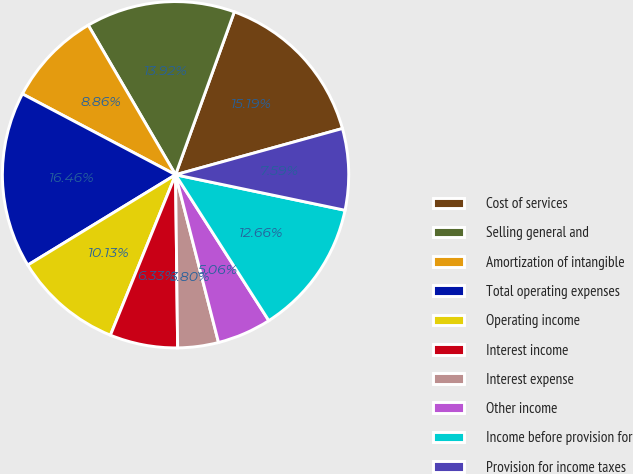Convert chart. <chart><loc_0><loc_0><loc_500><loc_500><pie_chart><fcel>Cost of services<fcel>Selling general and<fcel>Amortization of intangible<fcel>Total operating expenses<fcel>Operating income<fcel>Interest income<fcel>Interest expense<fcel>Other income<fcel>Income before provision for<fcel>Provision for income taxes<nl><fcel>15.19%<fcel>13.92%<fcel>8.86%<fcel>16.46%<fcel>10.13%<fcel>6.33%<fcel>3.8%<fcel>5.06%<fcel>12.66%<fcel>7.59%<nl></chart> 